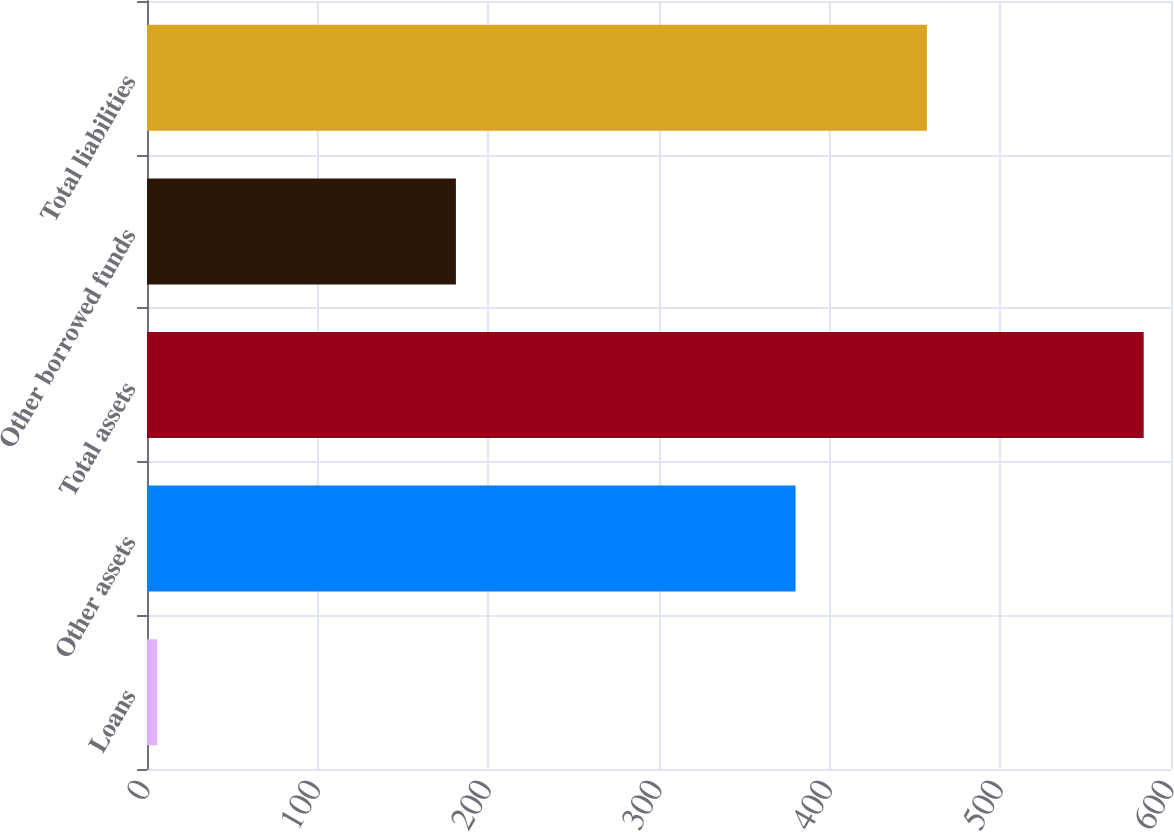Convert chart to OTSL. <chart><loc_0><loc_0><loc_500><loc_500><bar_chart><fcel>Loans<fcel>Other assets<fcel>Total assets<fcel>Other borrowed funds<fcel>Total liabilities<nl><fcel>6<fcel>380<fcel>584<fcel>181<fcel>457<nl></chart> 